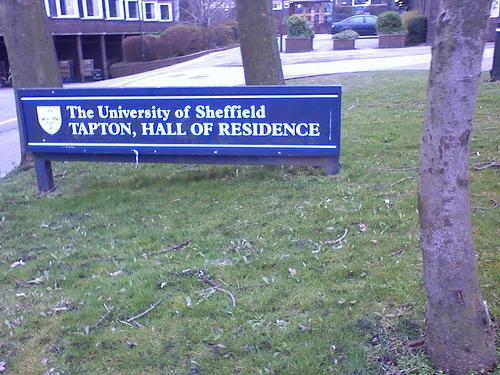Who lives in these buildings? students 